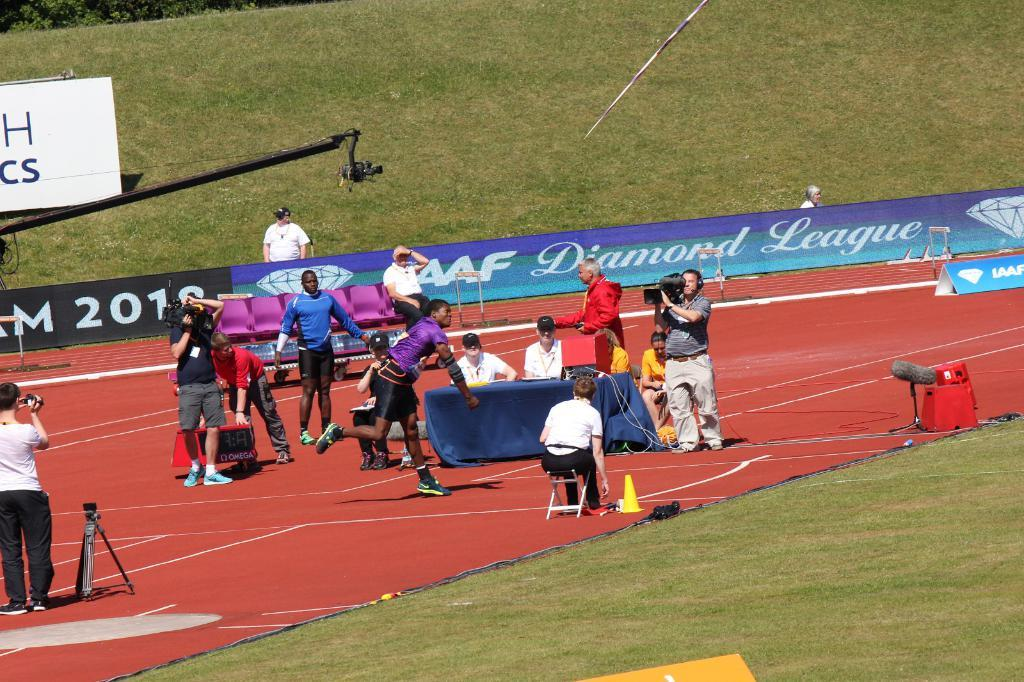What is the main subject in the foreground of the image? There is a crowd in the foreground of the image. What is the position of the crowd in relation to the ground? The crowd is on the ground. What equipment can be seen in the foreground of the image? There is a camera stand in the foreground of the image. What type of furniture is present in the foreground of the image? There are chairs and a table in the foreground of the image. What can be seen in the background of the image? There is a fence and grass in the background of the image. When was the image taken? The image was taken during the day. What type of wilderness stamp can be seen on the table in the image? There is no wilderness stamp present in the image. What type of fowl can be seen in the image? There is no fowl present in the image. 